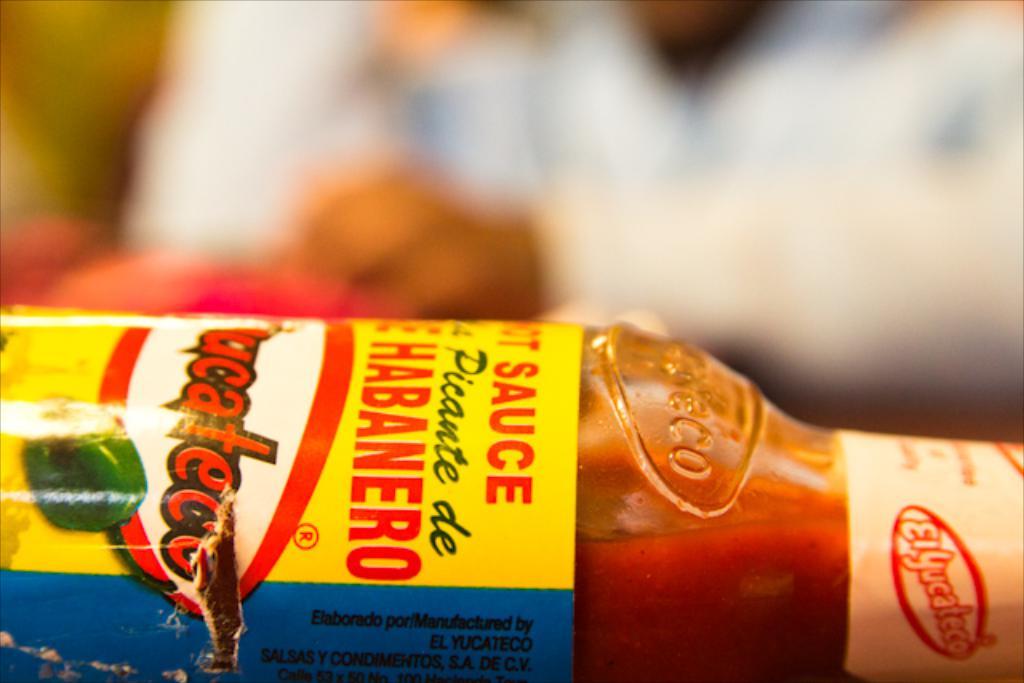Is this habanero sauce?
Your response must be concise. Yes. Where was this sauce made?
Provide a short and direct response. Unanswerable. 